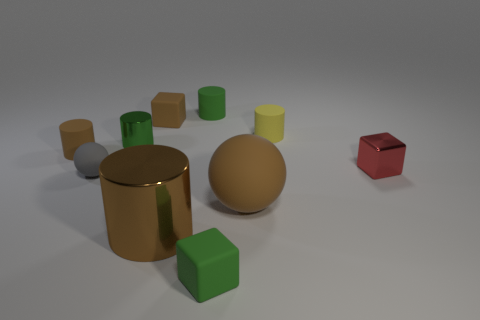Does the big matte object have the same color as the big metallic object?
Keep it short and to the point. Yes. Does the small gray thing have the same shape as the small object in front of the large brown shiny object?
Ensure brevity in your answer.  No. Is the number of small gray things in front of the tiny green metallic cylinder greater than the number of red rubber cylinders?
Your response must be concise. Yes. Are there fewer brown objects that are in front of the large metal thing than small matte balls?
Offer a terse response. Yes. What number of large rubber balls have the same color as the tiny metallic cylinder?
Keep it short and to the point. 0. What is the material of the brown thing that is both in front of the tiny gray sphere and left of the tiny green rubber cube?
Offer a terse response. Metal. Is the color of the shiny cylinder behind the small matte sphere the same as the tiny cylinder that is behind the yellow matte object?
Provide a succinct answer. Yes. What number of green things are either tiny metal cylinders or small rubber things?
Provide a short and direct response. 3. Are there fewer brown matte balls that are on the left side of the small green metal object than yellow matte objects in front of the brown cube?
Offer a terse response. Yes. Is there a gray rubber cube that has the same size as the brown rubber cylinder?
Your answer should be compact. No. 